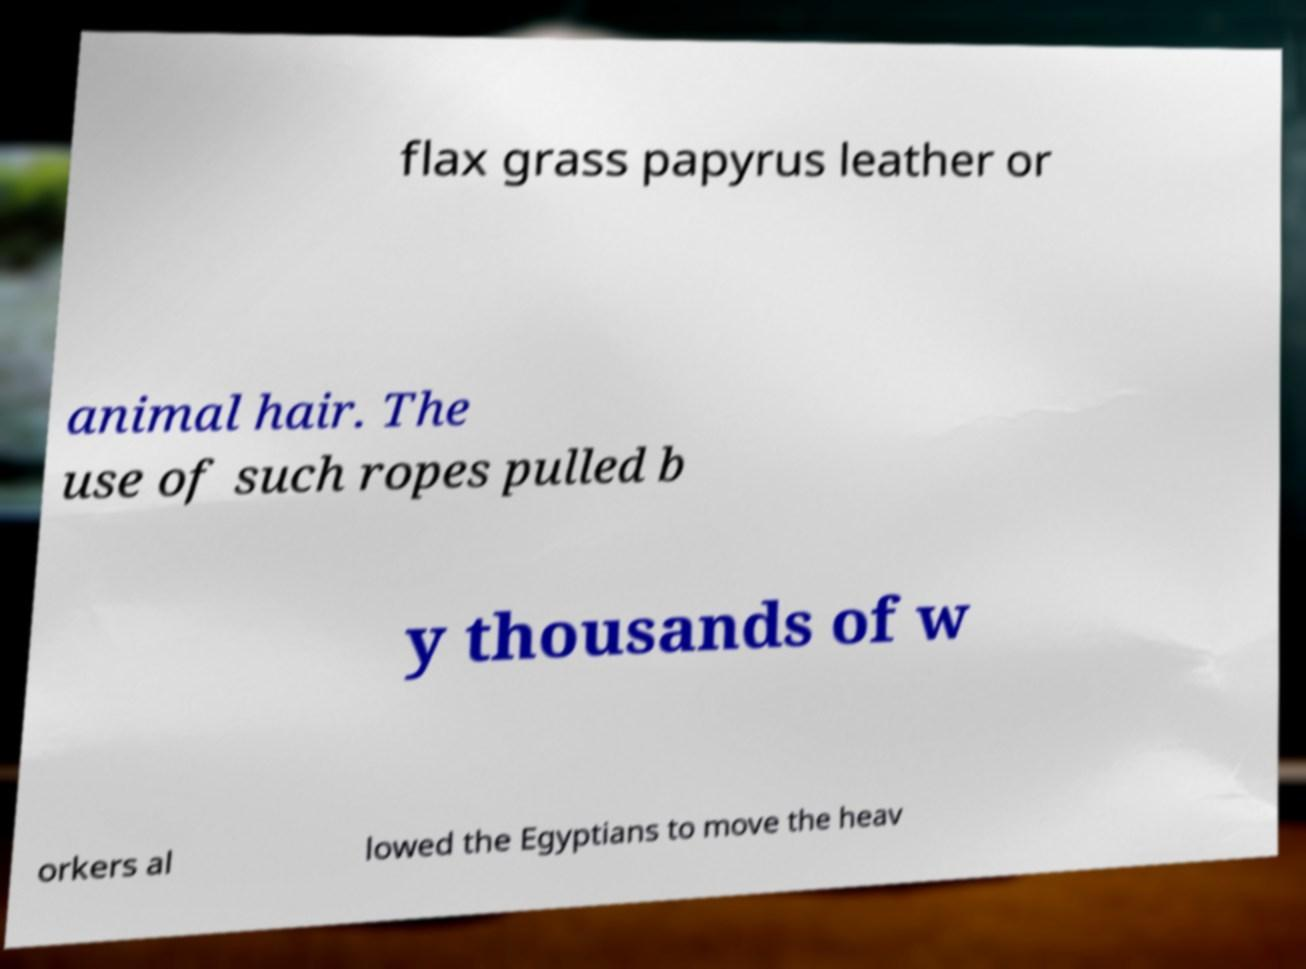Please read and relay the text visible in this image. What does it say? flax grass papyrus leather or animal hair. The use of such ropes pulled b y thousands of w orkers al lowed the Egyptians to move the heav 